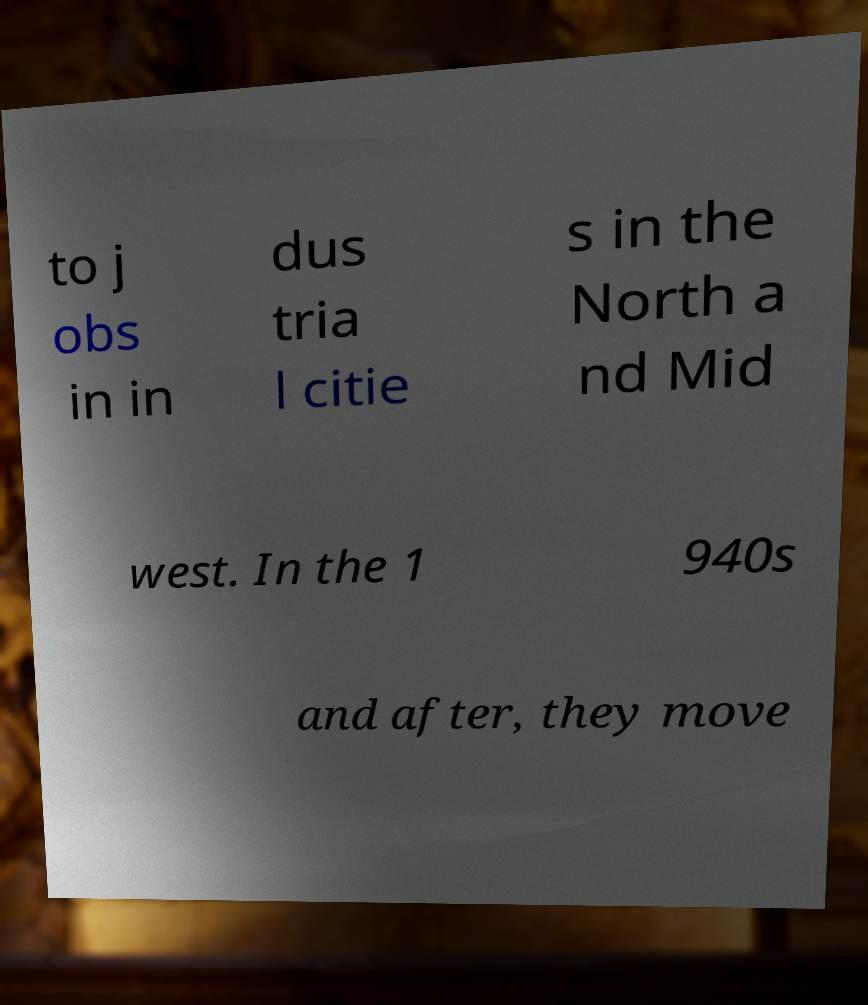Can you read and provide the text displayed in the image?This photo seems to have some interesting text. Can you extract and type it out for me? to j obs in in dus tria l citie s in the North a nd Mid west. In the 1 940s and after, they move 